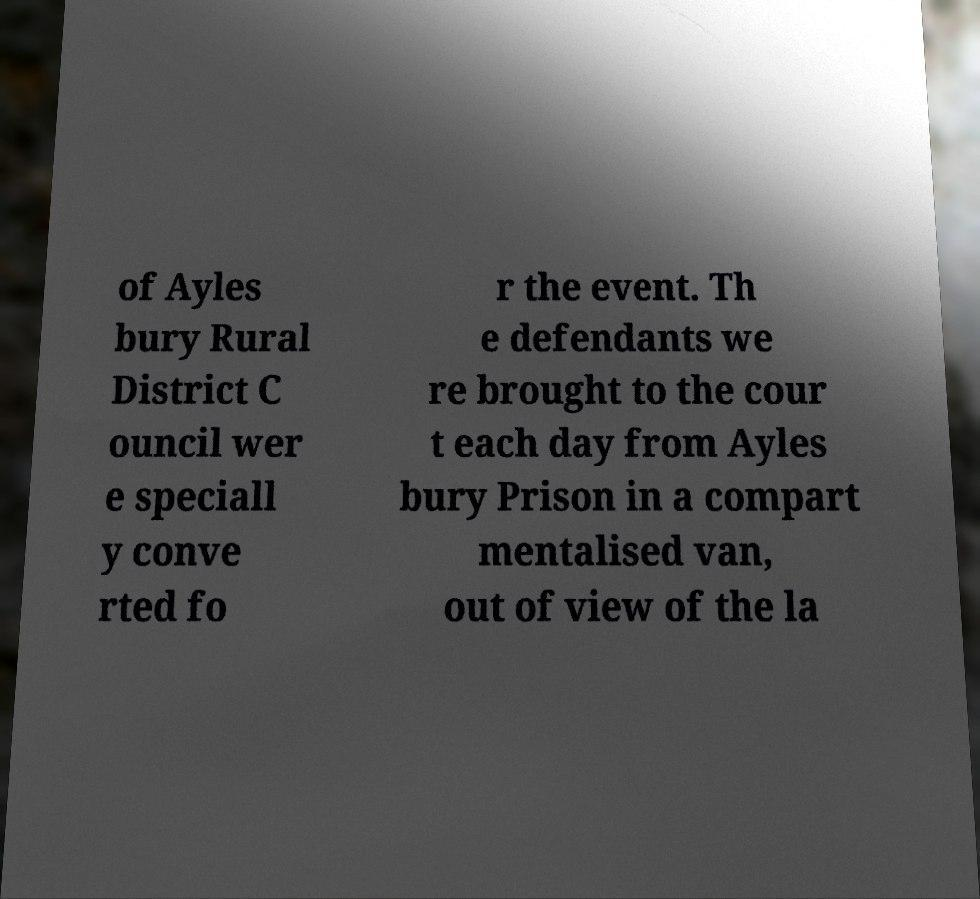Could you extract and type out the text from this image? of Ayles bury Rural District C ouncil wer e speciall y conve rted fo r the event. Th e defendants we re brought to the cour t each day from Ayles bury Prison in a compart mentalised van, out of view of the la 